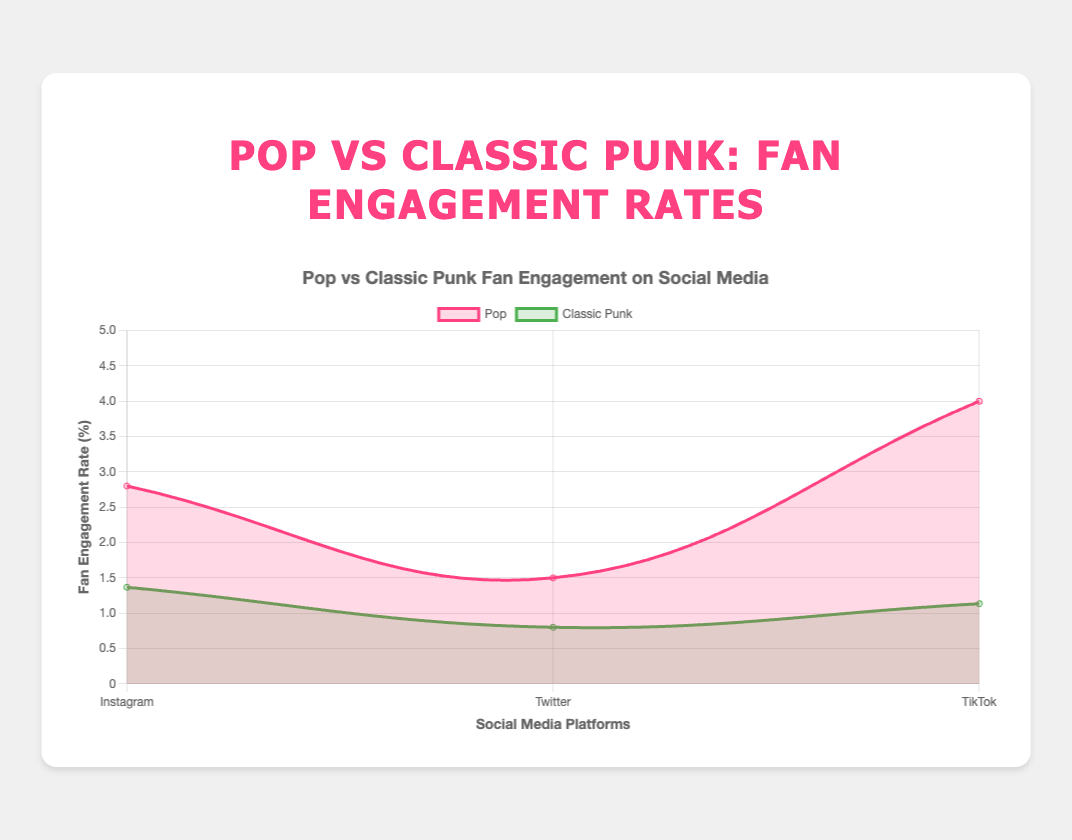What's the average fan engagement rate for pop artists on Instagram? To calculate the average fan engagement rate for pop artists on Instagram, sum up the engagement rates of Ariana Grande (2.8), Taylor Swift (3.5), and Dua Lipa (2.1), which is 2.8 + 3.5 + 2.1 = 8.4. Then divide by the number of artists (3). So, 8.4 / 3 = 2.8
Answer: 2.8 Which artist type has the highest fan engagement rate on TikTok? By looking at the TikTok engagement rates, the pop artists have higher engagement rates: Ariana Grande (4.0), Taylor Swift (3.8), and Dua Lipa (4.2), whereas the classic punk artists have lower rates: The Ramones (1.0), Sex Pistols (1.3), The Clash (1.1). Thus, pop artists have the highest engagement rates on TikTok.
Answer: Pop What's the difference in average fan engagement rates between pop and classic punk artists on Twitter? First, calculate the average fan engagement rate for pop artists on Twitter: (1.5 + 1.7 + 1.3) / 3 = 1.5. Then for classic punk artists on Twitter: (0.8 + 0.7 + 0.9) / 3 = 0.8. Finally, subtract the average rate for classic punk from pop: 1.5 - 0.8 = 0.7
Answer: 0.7 Which social media platform shows the greatest difference in fan engagement rates between pop and classic punk artists? Calculate the difference on each platform: Instagram (pop average 2.8, classic punk average 1.37, difference 1.43), Twitter (pop average 1.5, classic punk average 0.8, difference 0.7), TikTok (pop average 4.0, classic punk average 1.13, difference 2.87). The greatest difference is on TikTok with 2.87.
Answer: TikTok Is there any platform where classic punk artists have a higher fan engagement rate than 2.0? By inspecting the figure, none of the platforms show a fan engagement rate higher than 2.0 for classic punk artists.
Answer: No Compare the fan engagement rates of Dua Lipa and The Clash on Instagram. Who has a higher rate and by how much? Dua Lipa's engagement rate on Instagram is 2.1, and The Clash's rate is 1.4. The difference is 2.1 - 1.4 = 0.7, so Dua Lipa has a higher rate by 0.7.
Answer: Dua Lipa by 0.7 Which artist among the pop artists on Twitter has the lowest fan engagement rate? The fan engagement rates for pop artists on Twitter are: Ariana Grande (1.5), Taylor Swift (1.7), and Dua Lipa (1.3). Hence, Dua Lipa has the lowest rate.
Answer: Dua Lipa Looking at the visual representation of the chart, which artist type's line appears smoother and less variable? Observing the lines, the classic punk artists' line appears smoother and less variable compared to the pop artists' line, which shows more variation across platforms.
Answer: Classic Punk 